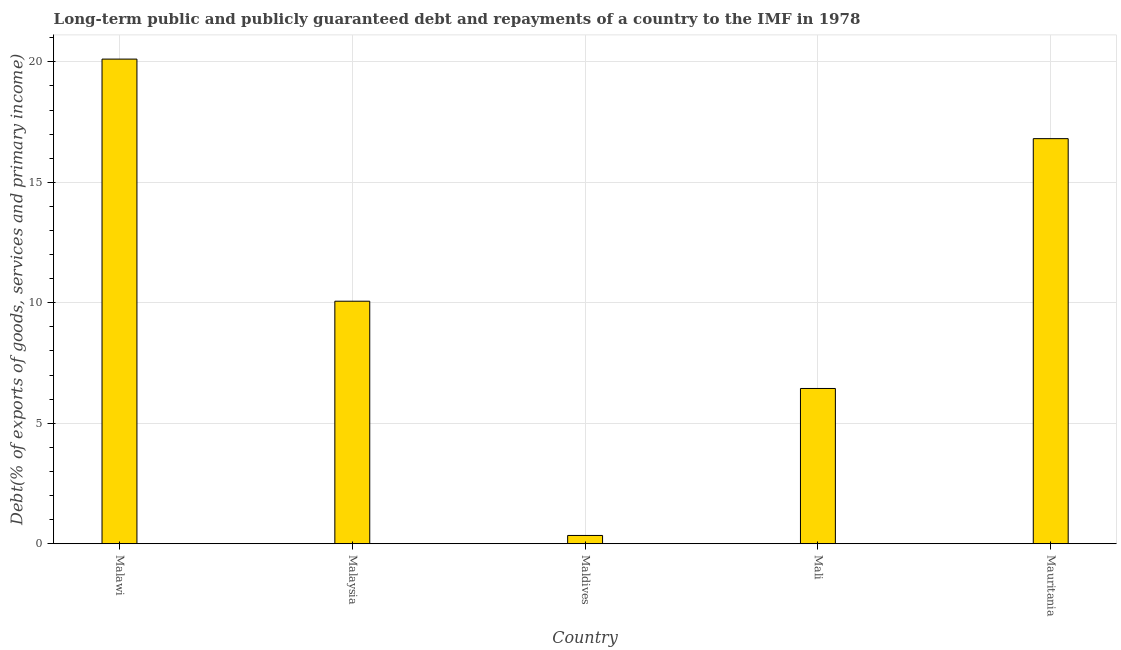Does the graph contain grids?
Your answer should be very brief. Yes. What is the title of the graph?
Provide a short and direct response. Long-term public and publicly guaranteed debt and repayments of a country to the IMF in 1978. What is the label or title of the Y-axis?
Offer a terse response. Debt(% of exports of goods, services and primary income). What is the debt service in Mauritania?
Provide a succinct answer. 16.81. Across all countries, what is the maximum debt service?
Your response must be concise. 20.11. Across all countries, what is the minimum debt service?
Keep it short and to the point. 0.34. In which country was the debt service maximum?
Provide a succinct answer. Malawi. In which country was the debt service minimum?
Offer a very short reply. Maldives. What is the sum of the debt service?
Ensure brevity in your answer.  53.78. What is the difference between the debt service in Malaysia and Maldives?
Provide a succinct answer. 9.72. What is the average debt service per country?
Provide a short and direct response. 10.76. What is the median debt service?
Your answer should be compact. 10.07. What is the ratio of the debt service in Malaysia to that in Maldives?
Give a very brief answer. 29.28. Is the debt service in Maldives less than that in Mali?
Provide a short and direct response. Yes. What is the difference between the highest and the second highest debt service?
Keep it short and to the point. 3.3. What is the difference between the highest and the lowest debt service?
Offer a very short reply. 19.77. In how many countries, is the debt service greater than the average debt service taken over all countries?
Provide a succinct answer. 2. How many bars are there?
Your answer should be compact. 5. Are all the bars in the graph horizontal?
Offer a terse response. No. How many countries are there in the graph?
Make the answer very short. 5. What is the difference between two consecutive major ticks on the Y-axis?
Your answer should be very brief. 5. Are the values on the major ticks of Y-axis written in scientific E-notation?
Give a very brief answer. No. What is the Debt(% of exports of goods, services and primary income) in Malawi?
Make the answer very short. 20.11. What is the Debt(% of exports of goods, services and primary income) in Malaysia?
Your response must be concise. 10.07. What is the Debt(% of exports of goods, services and primary income) in Maldives?
Offer a terse response. 0.34. What is the Debt(% of exports of goods, services and primary income) in Mali?
Make the answer very short. 6.44. What is the Debt(% of exports of goods, services and primary income) in Mauritania?
Offer a very short reply. 16.81. What is the difference between the Debt(% of exports of goods, services and primary income) in Malawi and Malaysia?
Keep it short and to the point. 10.05. What is the difference between the Debt(% of exports of goods, services and primary income) in Malawi and Maldives?
Your answer should be very brief. 19.77. What is the difference between the Debt(% of exports of goods, services and primary income) in Malawi and Mali?
Your response must be concise. 13.67. What is the difference between the Debt(% of exports of goods, services and primary income) in Malawi and Mauritania?
Offer a terse response. 3.3. What is the difference between the Debt(% of exports of goods, services and primary income) in Malaysia and Maldives?
Your answer should be very brief. 9.72. What is the difference between the Debt(% of exports of goods, services and primary income) in Malaysia and Mali?
Ensure brevity in your answer.  3.62. What is the difference between the Debt(% of exports of goods, services and primary income) in Malaysia and Mauritania?
Offer a terse response. -6.75. What is the difference between the Debt(% of exports of goods, services and primary income) in Maldives and Mali?
Provide a short and direct response. -6.1. What is the difference between the Debt(% of exports of goods, services and primary income) in Maldives and Mauritania?
Your answer should be very brief. -16.47. What is the difference between the Debt(% of exports of goods, services and primary income) in Mali and Mauritania?
Make the answer very short. -10.37. What is the ratio of the Debt(% of exports of goods, services and primary income) in Malawi to that in Malaysia?
Make the answer very short. 2. What is the ratio of the Debt(% of exports of goods, services and primary income) in Malawi to that in Maldives?
Provide a short and direct response. 58.52. What is the ratio of the Debt(% of exports of goods, services and primary income) in Malawi to that in Mali?
Your response must be concise. 3.12. What is the ratio of the Debt(% of exports of goods, services and primary income) in Malawi to that in Mauritania?
Your response must be concise. 1.2. What is the ratio of the Debt(% of exports of goods, services and primary income) in Malaysia to that in Maldives?
Your answer should be very brief. 29.28. What is the ratio of the Debt(% of exports of goods, services and primary income) in Malaysia to that in Mali?
Ensure brevity in your answer.  1.56. What is the ratio of the Debt(% of exports of goods, services and primary income) in Malaysia to that in Mauritania?
Give a very brief answer. 0.6. What is the ratio of the Debt(% of exports of goods, services and primary income) in Maldives to that in Mali?
Provide a succinct answer. 0.05. What is the ratio of the Debt(% of exports of goods, services and primary income) in Maldives to that in Mauritania?
Give a very brief answer. 0.02. What is the ratio of the Debt(% of exports of goods, services and primary income) in Mali to that in Mauritania?
Keep it short and to the point. 0.38. 